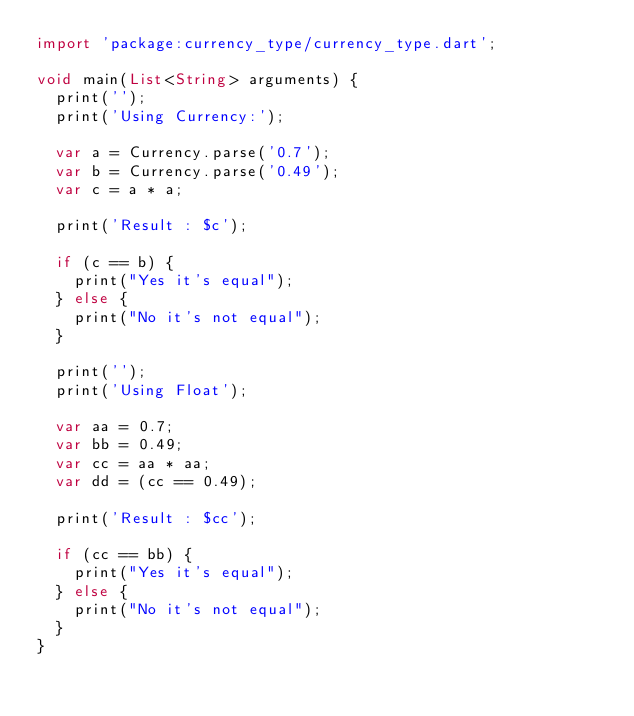<code> <loc_0><loc_0><loc_500><loc_500><_Dart_>import 'package:currency_type/currency_type.dart';

void main(List<String> arguments) {
  print('');
  print('Using Currency:');

  var a = Currency.parse('0.7');
  var b = Currency.parse('0.49');
  var c = a * a;

  print('Result : $c');

  if (c == b) {
    print("Yes it's equal");
  } else {
    print("No it's not equal");
  }

  print('');
  print('Using Float');

  var aa = 0.7;
  var bb = 0.49;
  var cc = aa * aa;
  var dd = (cc == 0.49);

  print('Result : $cc');

  if (cc == bb) {
    print("Yes it's equal");
  } else {
    print("No it's not equal");
  }
}
</code> 